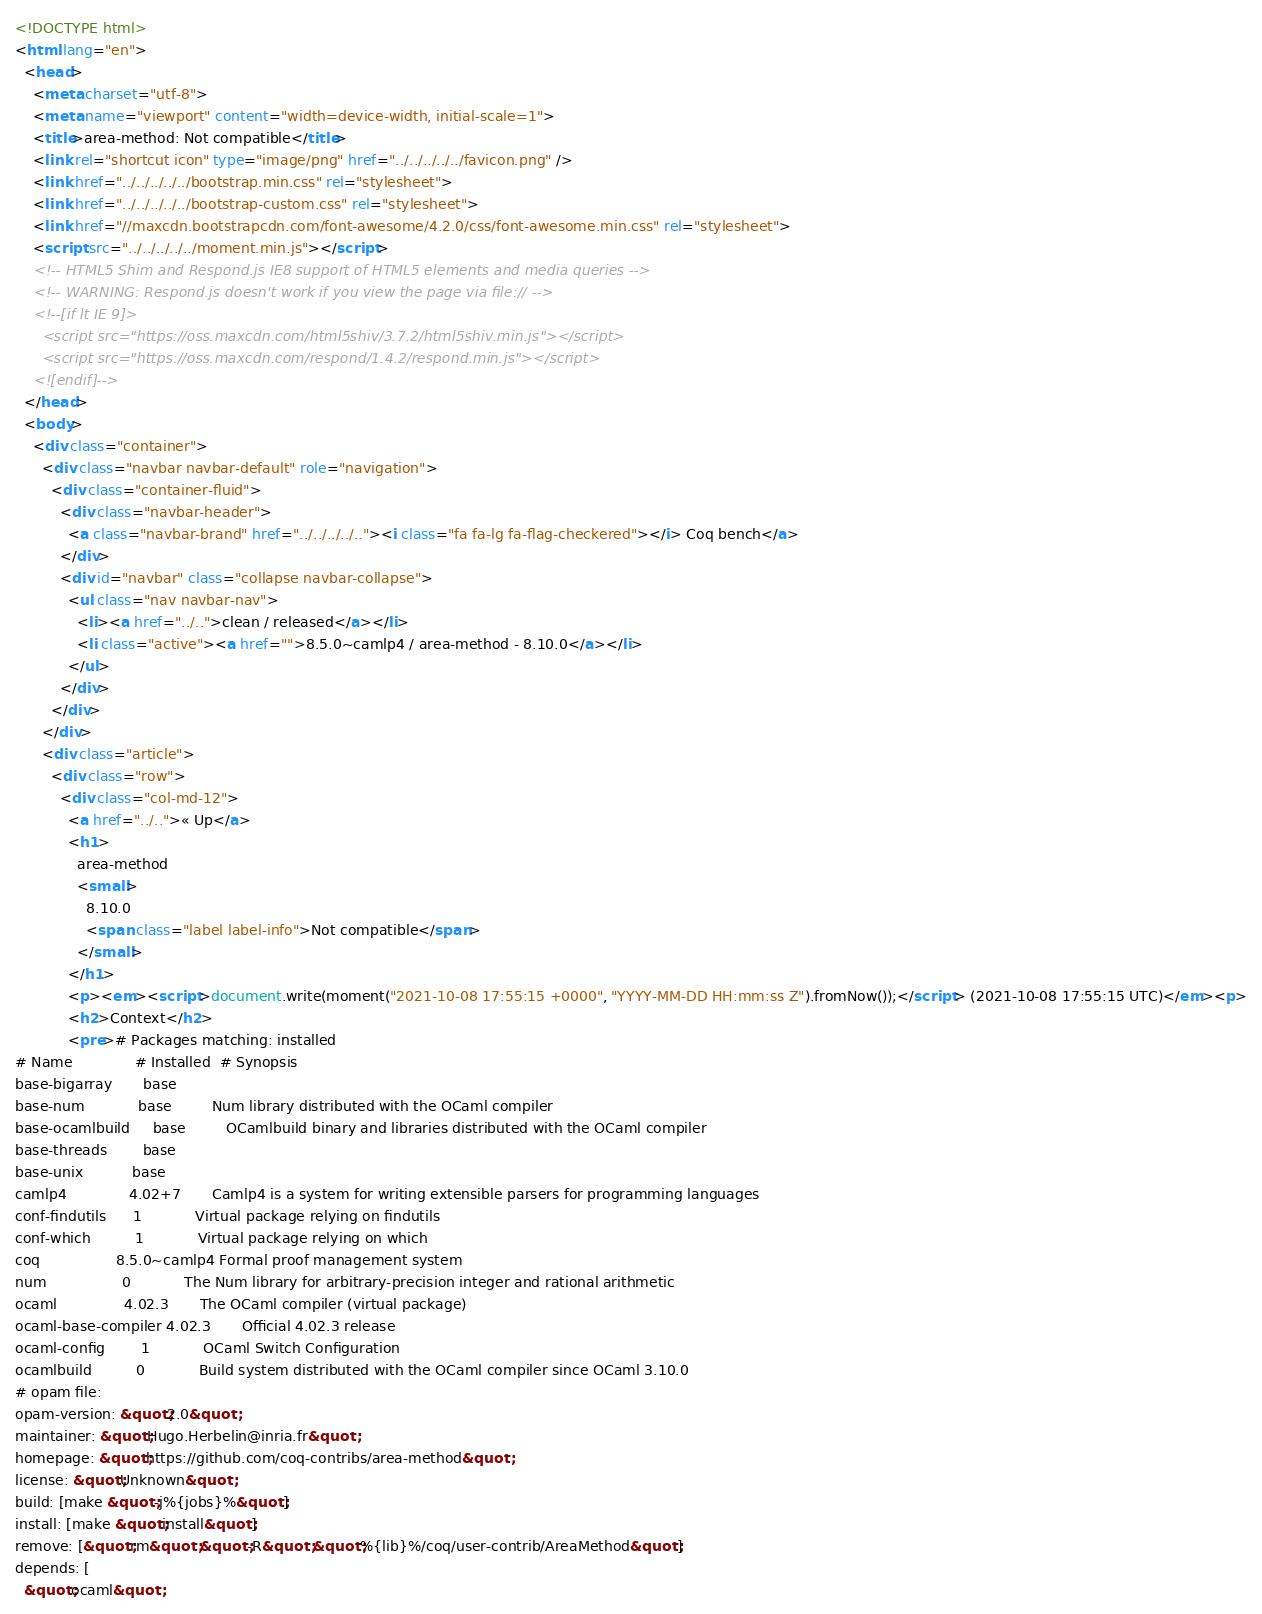<code> <loc_0><loc_0><loc_500><loc_500><_HTML_><!DOCTYPE html>
<html lang="en">
  <head>
    <meta charset="utf-8">
    <meta name="viewport" content="width=device-width, initial-scale=1">
    <title>area-method: Not compatible</title>
    <link rel="shortcut icon" type="image/png" href="../../../../../favicon.png" />
    <link href="../../../../../bootstrap.min.css" rel="stylesheet">
    <link href="../../../../../bootstrap-custom.css" rel="stylesheet">
    <link href="//maxcdn.bootstrapcdn.com/font-awesome/4.2.0/css/font-awesome.min.css" rel="stylesheet">
    <script src="../../../../../moment.min.js"></script>
    <!-- HTML5 Shim and Respond.js IE8 support of HTML5 elements and media queries -->
    <!-- WARNING: Respond.js doesn't work if you view the page via file:// -->
    <!--[if lt IE 9]>
      <script src="https://oss.maxcdn.com/html5shiv/3.7.2/html5shiv.min.js"></script>
      <script src="https://oss.maxcdn.com/respond/1.4.2/respond.min.js"></script>
    <![endif]-->
  </head>
  <body>
    <div class="container">
      <div class="navbar navbar-default" role="navigation">
        <div class="container-fluid">
          <div class="navbar-header">
            <a class="navbar-brand" href="../../../../.."><i class="fa fa-lg fa-flag-checkered"></i> Coq bench</a>
          </div>
          <div id="navbar" class="collapse navbar-collapse">
            <ul class="nav navbar-nav">
              <li><a href="../..">clean / released</a></li>
              <li class="active"><a href="">8.5.0~camlp4 / area-method - 8.10.0</a></li>
            </ul>
          </div>
        </div>
      </div>
      <div class="article">
        <div class="row">
          <div class="col-md-12">
            <a href="../..">« Up</a>
            <h1>
              area-method
              <small>
                8.10.0
                <span class="label label-info">Not compatible</span>
              </small>
            </h1>
            <p><em><script>document.write(moment("2021-10-08 17:55:15 +0000", "YYYY-MM-DD HH:mm:ss Z").fromNow());</script> (2021-10-08 17:55:15 UTC)</em><p>
            <h2>Context</h2>
            <pre># Packages matching: installed
# Name              # Installed  # Synopsis
base-bigarray       base
base-num            base         Num library distributed with the OCaml compiler
base-ocamlbuild     base         OCamlbuild binary and libraries distributed with the OCaml compiler
base-threads        base
base-unix           base
camlp4              4.02+7       Camlp4 is a system for writing extensible parsers for programming languages
conf-findutils      1            Virtual package relying on findutils
conf-which          1            Virtual package relying on which
coq                 8.5.0~camlp4 Formal proof management system
num                 0            The Num library for arbitrary-precision integer and rational arithmetic
ocaml               4.02.3       The OCaml compiler (virtual package)
ocaml-base-compiler 4.02.3       Official 4.02.3 release
ocaml-config        1            OCaml Switch Configuration
ocamlbuild          0            Build system distributed with the OCaml compiler since OCaml 3.10.0
# opam file:
opam-version: &quot;2.0&quot;
maintainer: &quot;Hugo.Herbelin@inria.fr&quot;
homepage: &quot;https://github.com/coq-contribs/area-method&quot;
license: &quot;Unknown&quot;
build: [make &quot;-j%{jobs}%&quot;]
install: [make &quot;install&quot;]
remove: [&quot;rm&quot; &quot;-R&quot; &quot;%{lib}%/coq/user-contrib/AreaMethod&quot;]
depends: [
  &quot;ocaml&quot;</code> 